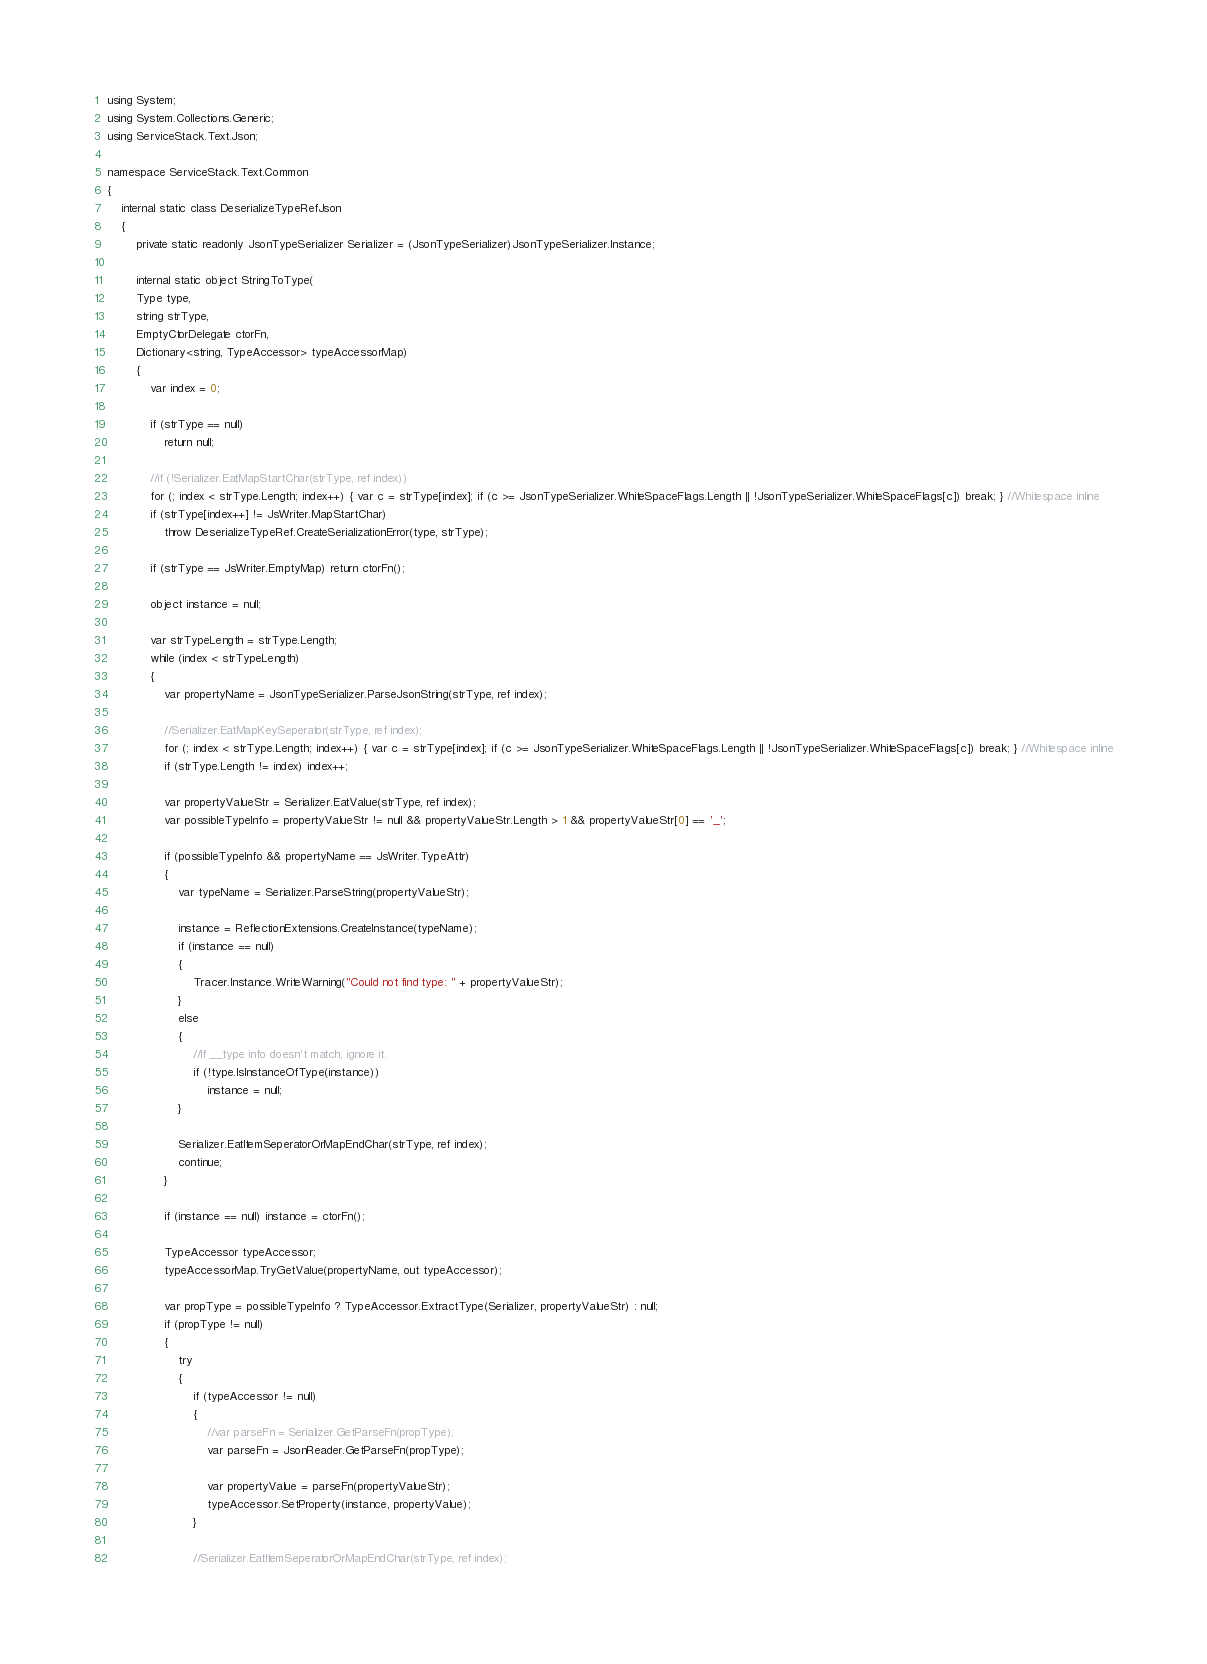Convert code to text. <code><loc_0><loc_0><loc_500><loc_500><_C#_>using System;
using System.Collections.Generic;
using ServiceStack.Text.Json;

namespace ServiceStack.Text.Common
{
	internal static class DeserializeTypeRefJson
	{
		private static readonly JsonTypeSerializer Serializer = (JsonTypeSerializer)JsonTypeSerializer.Instance;

		internal static object StringToType(
		Type type,
		string strType,
		EmptyCtorDelegate ctorFn,
		Dictionary<string, TypeAccessor> typeAccessorMap)
		{
			var index = 0;

			if (strType == null)
				return null;

			//if (!Serializer.EatMapStartChar(strType, ref index))
			for (; index < strType.Length; index++) { var c = strType[index]; if (c >= JsonTypeSerializer.WhiteSpaceFlags.Length || !JsonTypeSerializer.WhiteSpaceFlags[c]) break; } //Whitespace inline
			if (strType[index++] != JsWriter.MapStartChar)
				throw DeserializeTypeRef.CreateSerializationError(type, strType);

			if (strType == JsWriter.EmptyMap) return ctorFn();

			object instance = null;

			var strTypeLength = strType.Length;
			while (index < strTypeLength)
			{
				var propertyName = JsonTypeSerializer.ParseJsonString(strType, ref index);

				//Serializer.EatMapKeySeperator(strType, ref index);
				for (; index < strType.Length; index++) { var c = strType[index]; if (c >= JsonTypeSerializer.WhiteSpaceFlags.Length || !JsonTypeSerializer.WhiteSpaceFlags[c]) break; } //Whitespace inline
				if (strType.Length != index) index++;

				var propertyValueStr = Serializer.EatValue(strType, ref index);
				var possibleTypeInfo = propertyValueStr != null && propertyValueStr.Length > 1 && propertyValueStr[0] == '_';

				if (possibleTypeInfo && propertyName == JsWriter.TypeAttr)
				{
					var typeName = Serializer.ParseString(propertyValueStr);

					instance = ReflectionExtensions.CreateInstance(typeName);
					if (instance == null)
					{
						Tracer.Instance.WriteWarning("Could not find type: " + propertyValueStr);
					}
					else
					{
						//If __type info doesn't match, ignore it.
						if (!type.IsInstanceOfType(instance))
							instance = null;
					}

					Serializer.EatItemSeperatorOrMapEndChar(strType, ref index);
					continue;
				}

				if (instance == null) instance = ctorFn();

				TypeAccessor typeAccessor;
				typeAccessorMap.TryGetValue(propertyName, out typeAccessor);

				var propType = possibleTypeInfo ? TypeAccessor.ExtractType(Serializer, propertyValueStr) : null;
				if (propType != null)
				{
					try
					{
						if (typeAccessor != null)
						{
							//var parseFn = Serializer.GetParseFn(propType);
							var parseFn = JsonReader.GetParseFn(propType);

							var propertyValue = parseFn(propertyValueStr);
							typeAccessor.SetProperty(instance, propertyValue);
						}

						//Serializer.EatItemSeperatorOrMapEndChar(strType, ref index);</code> 